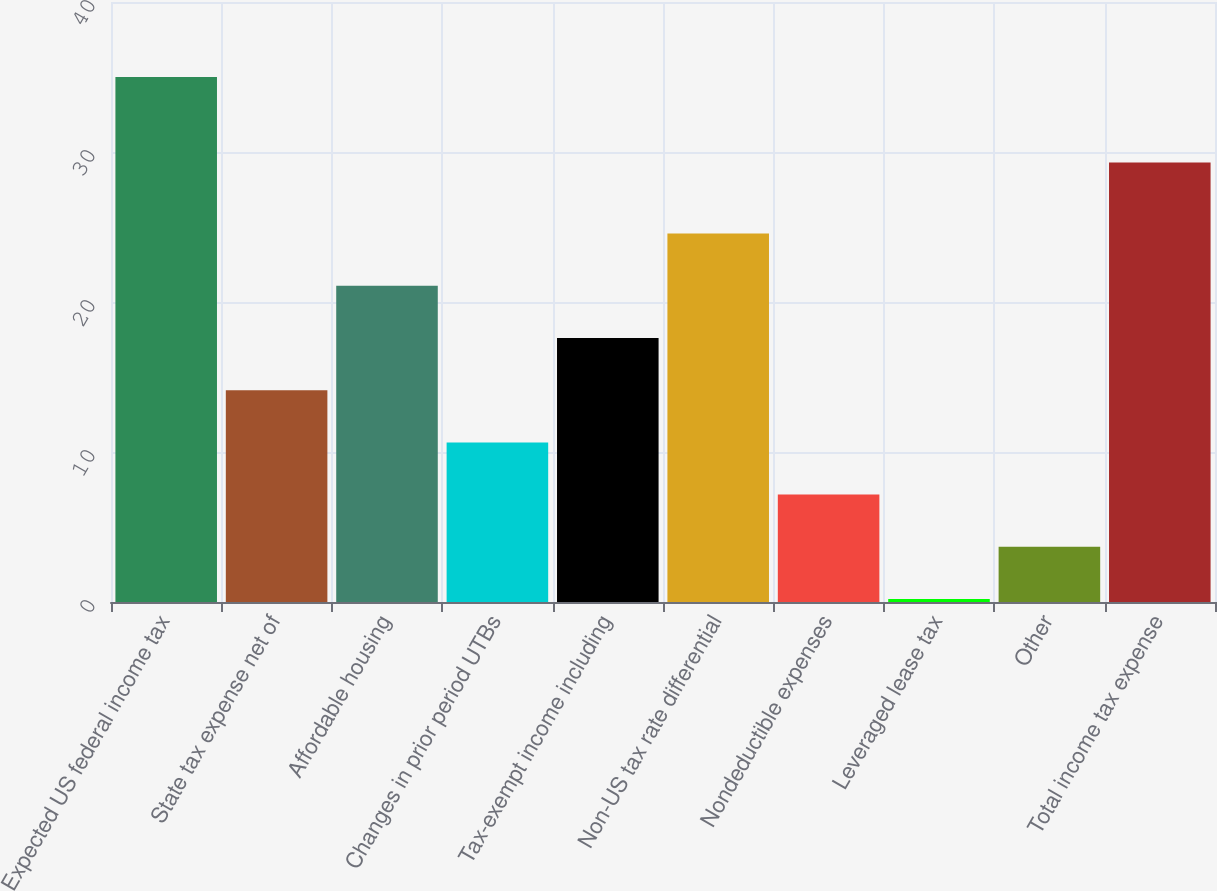Convert chart to OTSL. <chart><loc_0><loc_0><loc_500><loc_500><bar_chart><fcel>Expected US federal income tax<fcel>State tax expense net of<fcel>Affordable housing<fcel>Changes in prior period UTBs<fcel>Tax-exempt income including<fcel>Non-US tax rate differential<fcel>Nondeductible expenses<fcel>Leveraged lease tax<fcel>Other<fcel>Total income tax expense<nl><fcel>35<fcel>14.12<fcel>21.08<fcel>10.64<fcel>17.6<fcel>24.56<fcel>7.16<fcel>0.2<fcel>3.68<fcel>29.3<nl></chart> 